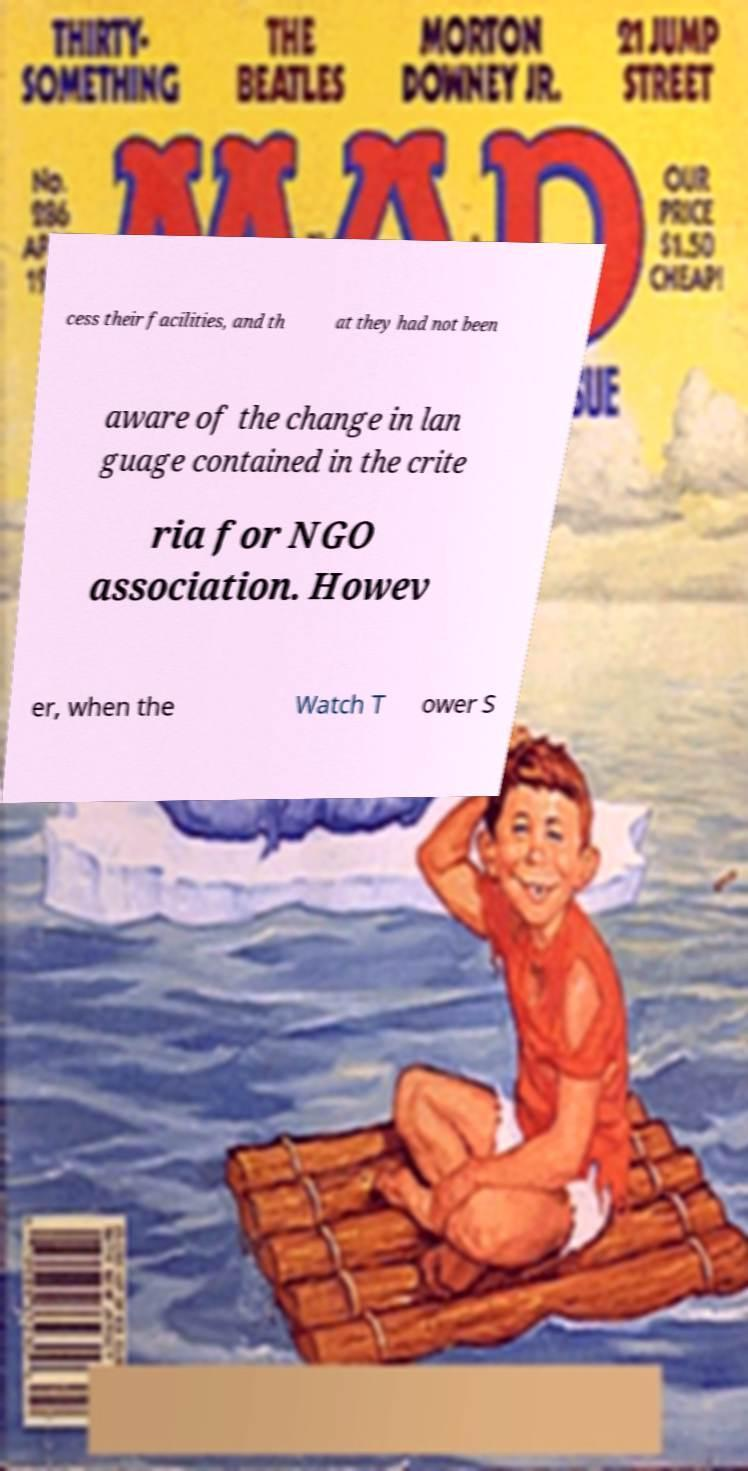What messages or text are displayed in this image? I need them in a readable, typed format. cess their facilities, and th at they had not been aware of the change in lan guage contained in the crite ria for NGO association. Howev er, when the Watch T ower S 